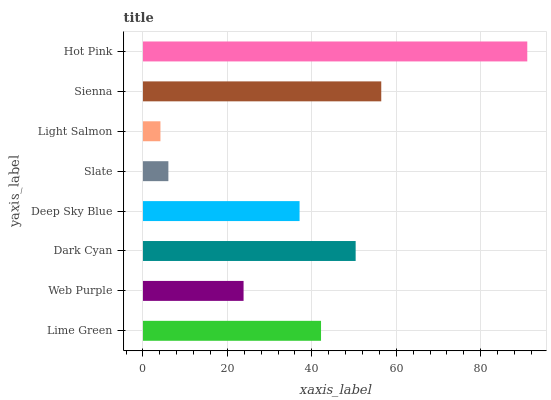Is Light Salmon the minimum?
Answer yes or no. Yes. Is Hot Pink the maximum?
Answer yes or no. Yes. Is Web Purple the minimum?
Answer yes or no. No. Is Web Purple the maximum?
Answer yes or no. No. Is Lime Green greater than Web Purple?
Answer yes or no. Yes. Is Web Purple less than Lime Green?
Answer yes or no. Yes. Is Web Purple greater than Lime Green?
Answer yes or no. No. Is Lime Green less than Web Purple?
Answer yes or no. No. Is Lime Green the high median?
Answer yes or no. Yes. Is Deep Sky Blue the low median?
Answer yes or no. Yes. Is Deep Sky Blue the high median?
Answer yes or no. No. Is Dark Cyan the low median?
Answer yes or no. No. 